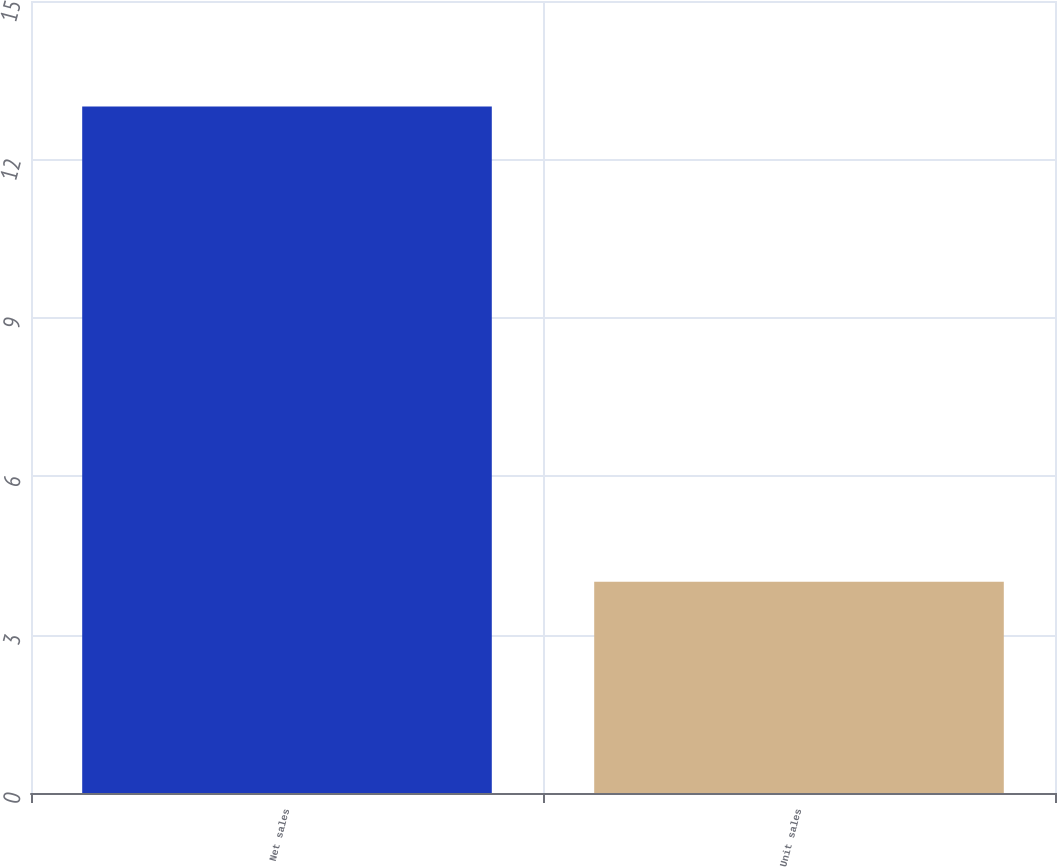Convert chart to OTSL. <chart><loc_0><loc_0><loc_500><loc_500><bar_chart><fcel>Net sales<fcel>Unit sales<nl><fcel>13<fcel>4<nl></chart> 